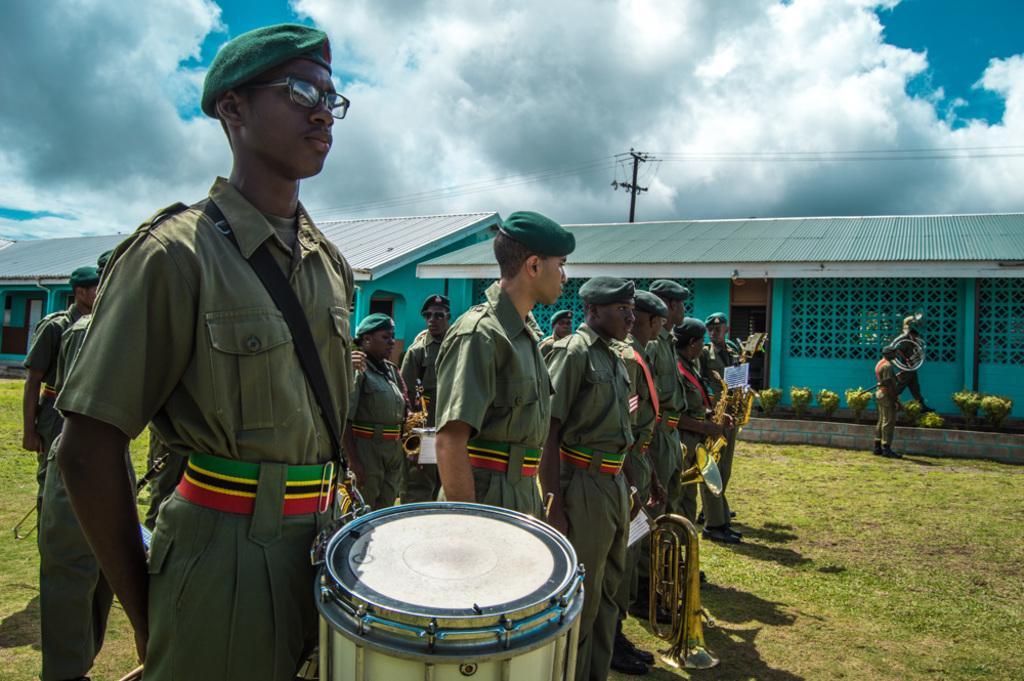Could you give a brief overview of what you see in this image? At the top we can see sky with clouds. Here we can see houses and a pole. Near to the house we can see plants and few men are standing in a uniform and playing musical instruments. This is a fresh green grass. 